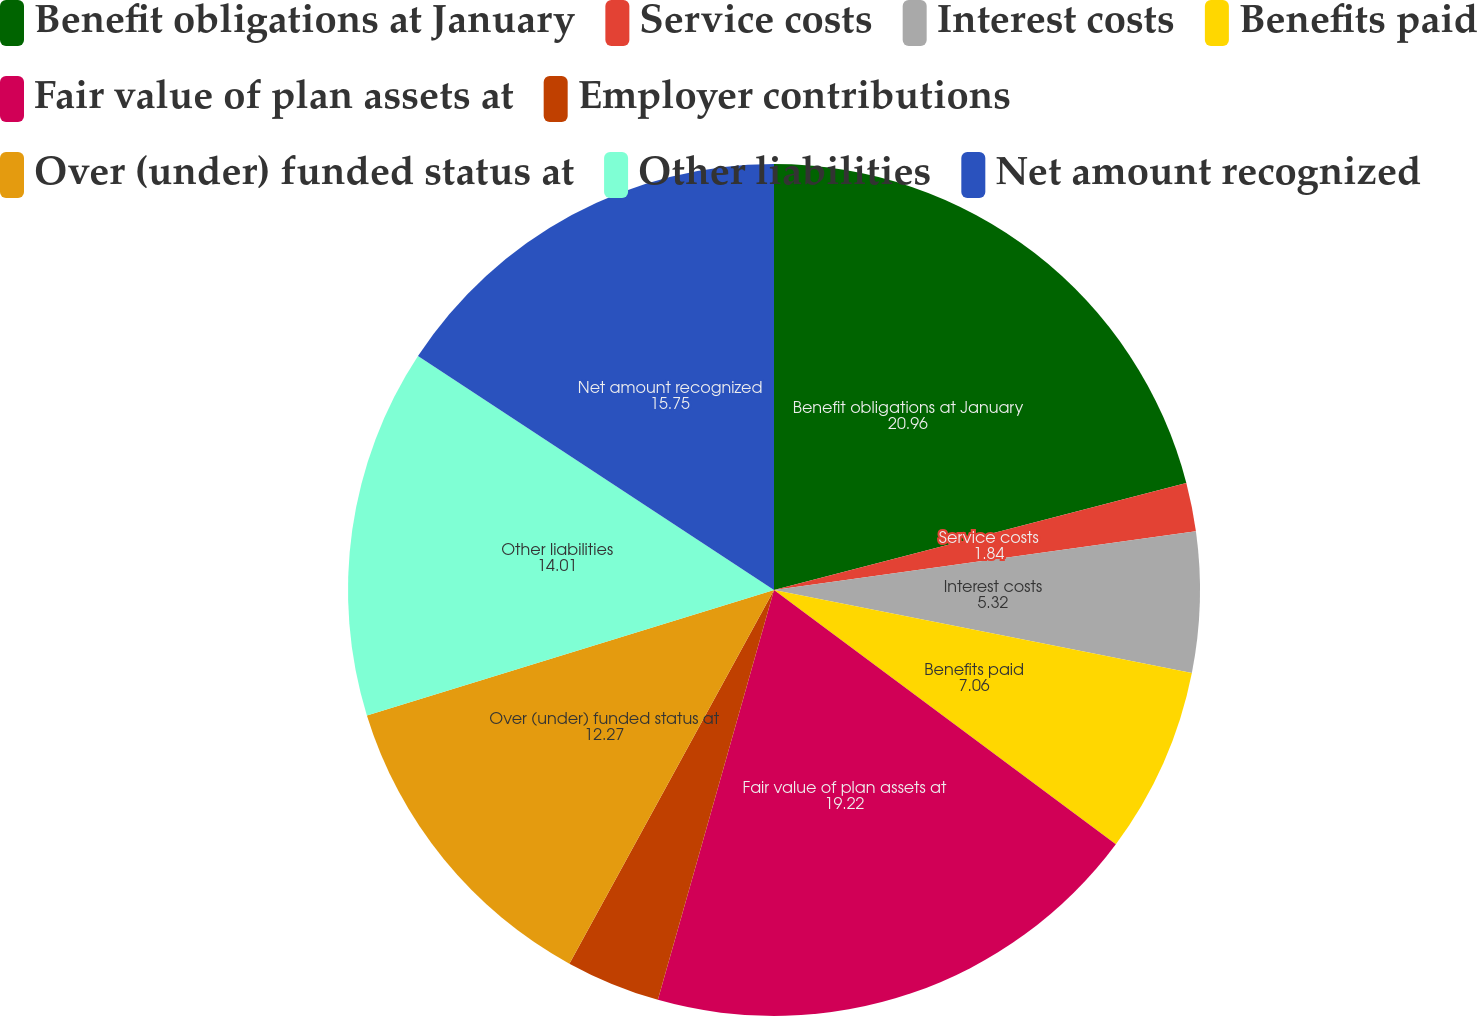<chart> <loc_0><loc_0><loc_500><loc_500><pie_chart><fcel>Benefit obligations at January<fcel>Service costs<fcel>Interest costs<fcel>Benefits paid<fcel>Fair value of plan assets at<fcel>Employer contributions<fcel>Over (under) funded status at<fcel>Other liabilities<fcel>Net amount recognized<nl><fcel>20.96%<fcel>1.84%<fcel>5.32%<fcel>7.06%<fcel>19.22%<fcel>3.58%<fcel>12.27%<fcel>14.01%<fcel>15.75%<nl></chart> 